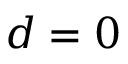<formula> <loc_0><loc_0><loc_500><loc_500>d = 0</formula> 